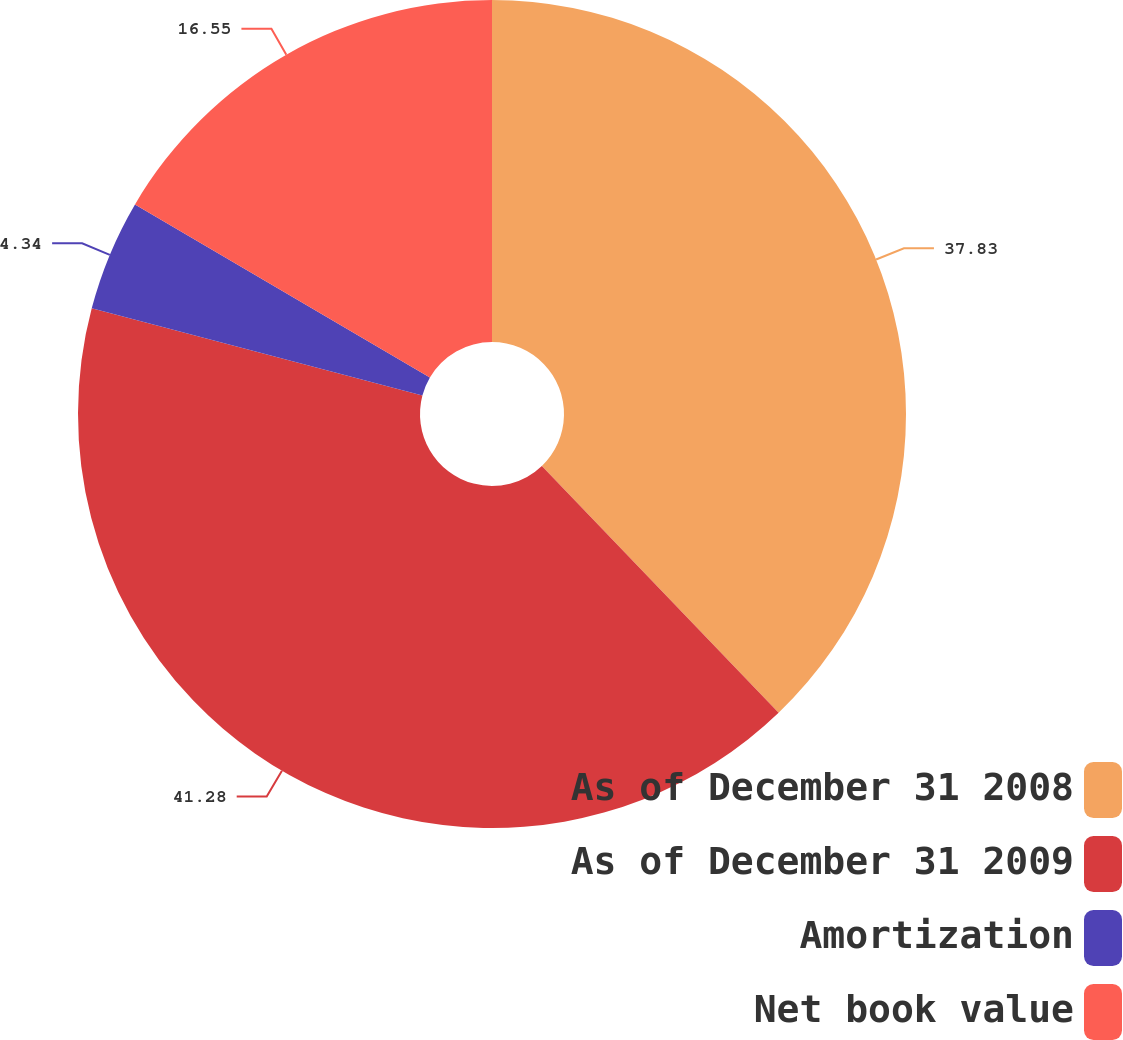Convert chart to OTSL. <chart><loc_0><loc_0><loc_500><loc_500><pie_chart><fcel>As of December 31 2008<fcel>As of December 31 2009<fcel>Amortization<fcel>Net book value<nl><fcel>37.83%<fcel>41.28%<fcel>4.34%<fcel>16.55%<nl></chart> 